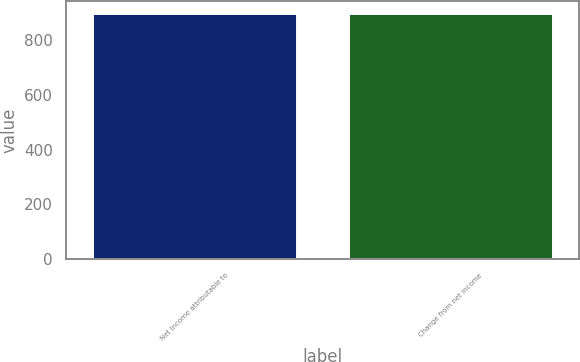Convert chart. <chart><loc_0><loc_0><loc_500><loc_500><bar_chart><fcel>Net income attributable to<fcel>Change from net income<nl><fcel>898<fcel>898.1<nl></chart> 